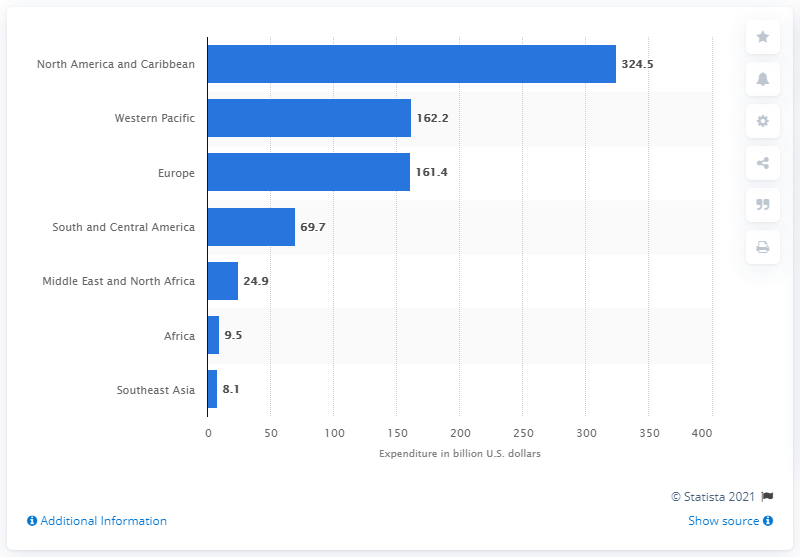Identify some key points in this picture. The North American and Caribbean region spent approximately 324.5 billion U.S. dollars on diabetes care in 2019. 